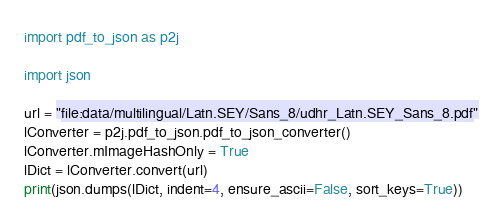<code> <loc_0><loc_0><loc_500><loc_500><_Python_>import pdf_to_json as p2j

import json

url = "file:data/multilingual/Latn.SEY/Sans_8/udhr_Latn.SEY_Sans_8.pdf"
lConverter = p2j.pdf_to_json.pdf_to_json_converter()
lConverter.mImageHashOnly = True
lDict = lConverter.convert(url)
print(json.dumps(lDict, indent=4, ensure_ascii=False, sort_keys=True))
</code> 